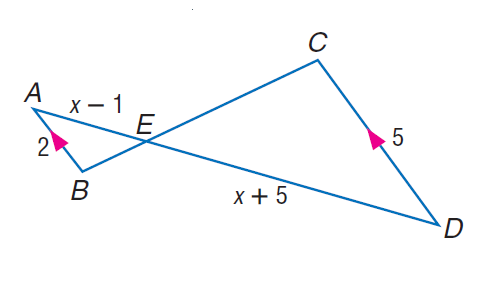Answer the mathemtical geometry problem and directly provide the correct option letter.
Question: Find A E.
Choices: A: 3 B: 4 C: 6 D: 11 B 